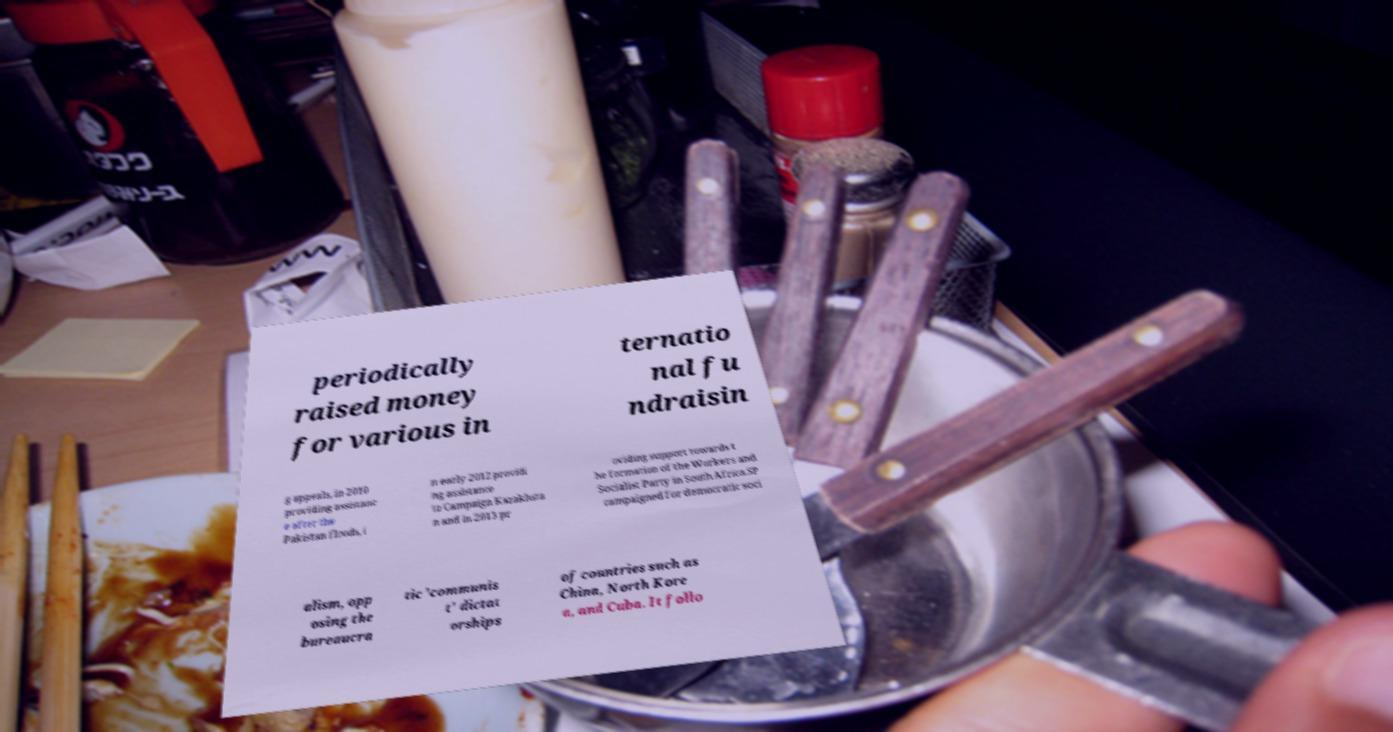Please identify and transcribe the text found in this image. periodically raised money for various in ternatio nal fu ndraisin g appeals, in 2010 providing assistanc e after the Pakistan floods, i n early 2012 providi ng assistance to Campaign Kazakhsta n and in 2013 pr oviding support towards t he formation of the Workers and Socialist Party in South Africa.SP campaigned for democratic soci alism, opp osing the bureaucra tic 'communis t' dictat orships of countries such as China, North Kore a, and Cuba. It follo 